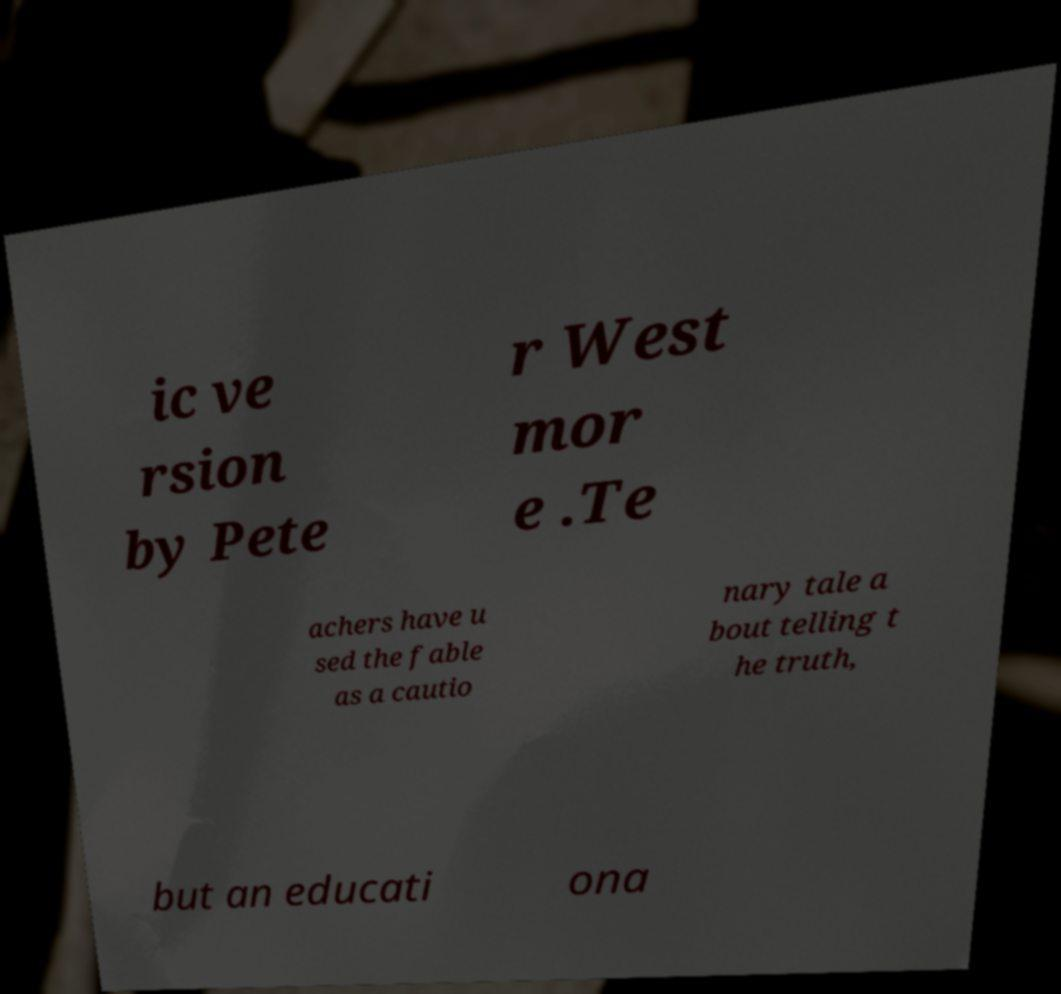For documentation purposes, I need the text within this image transcribed. Could you provide that? ic ve rsion by Pete r West mor e .Te achers have u sed the fable as a cautio nary tale a bout telling t he truth, but an educati ona 